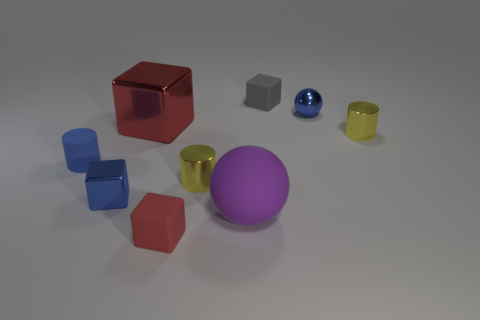Subtract all green blocks. Subtract all gray balls. How many blocks are left? 4 Add 1 tiny yellow cylinders. How many objects exist? 10 Subtract all blocks. How many objects are left? 5 Subtract all large green things. Subtract all tiny cylinders. How many objects are left? 6 Add 1 blue rubber cylinders. How many blue rubber cylinders are left? 2 Add 5 tiny metal spheres. How many tiny metal spheres exist? 6 Subtract 0 gray cylinders. How many objects are left? 9 